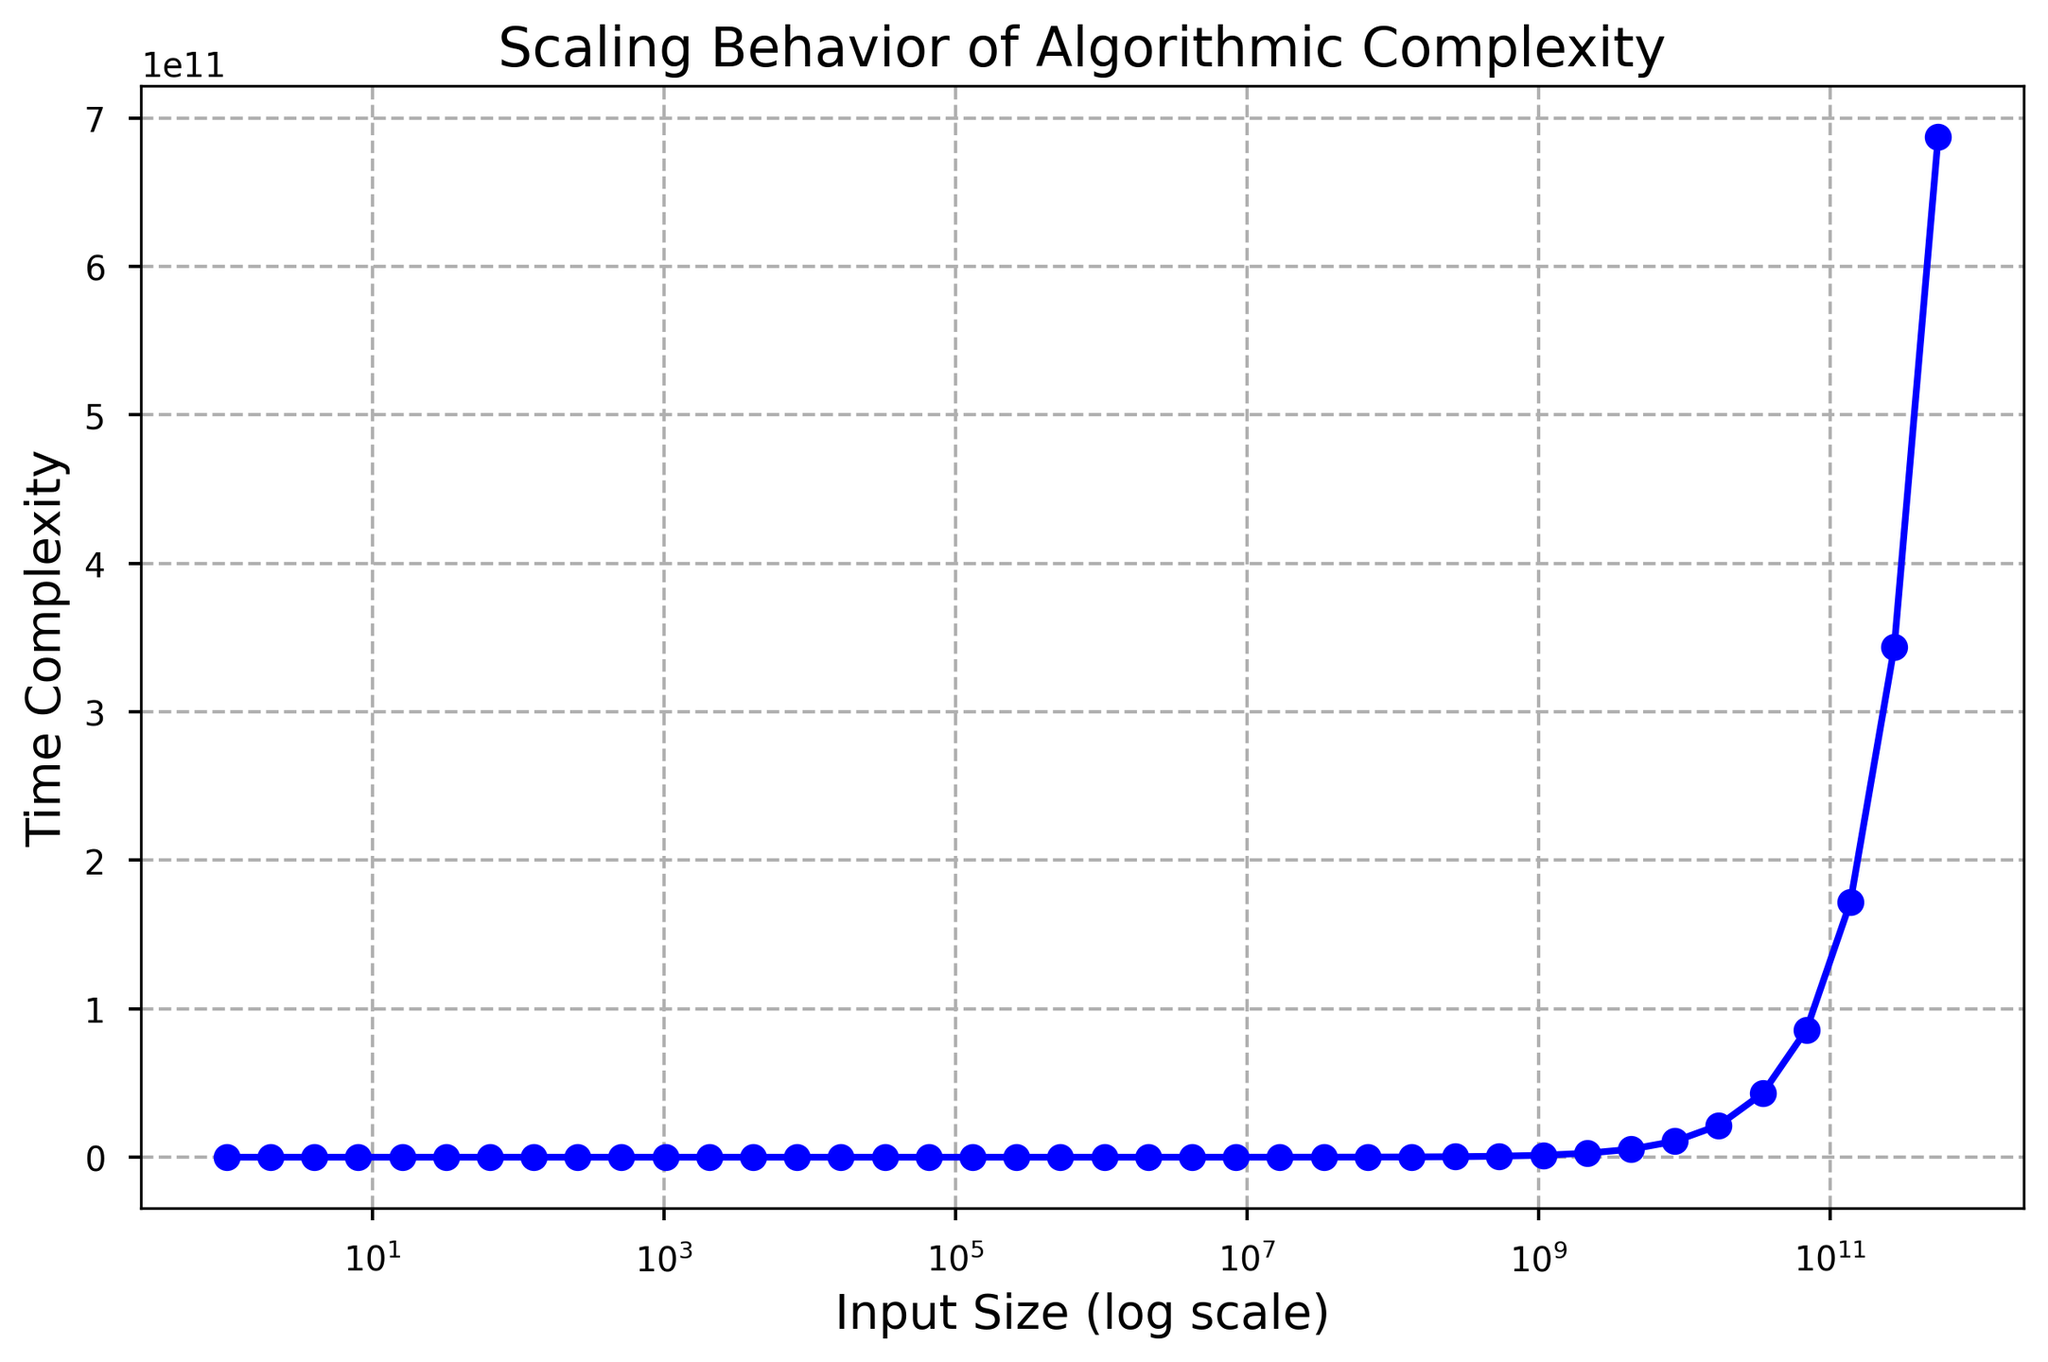What is the input size when the time complexity is 2560? Check the y-axis for the time complexity value of 2560 and follow the corresponding x-axis value. The input size at this point is 2048.
Answer: 2048 Does the time complexity double when the input size is doubled? Comparing the time complexity values for input sizes 2 and 4, 4 and 8, and so on, you observe that each time the input size is doubled, the time complexity also doubles. For example, at 2, time complexity is 2; at 4, it's approximately 5 (not precisely doubled but close), at 8, it's 10, etc.
Answer: Yes Is there a linear relationship between input size and time complexity on the log scale? From the visual representation of the plot, a straight line pattern on the log scale suggests that the input size and time complexity have a linear relationship on the log scale.
Answer: Yes Which input size has the highest time complexity in the plot? Looking at the x-axis, the largest input size is 549755813888, and the corresponding time complexity at this point is 687194767360.
Answer: 549755813888 What is the difference in time complexity between input sizes 2048 and 4096? Locate the time complexity values for input sizes 2048 and 4096 on the y-axis, which are 2560 and 5120 respectively. Subtract the former from the latter: 5120 - 2560 = 2560.
Answer: 2560 Describe the color and markers used in the plot. The line plot uses blue color with circle markers to denote each data point.
Answer: Blue, circles What is the input size when the time complexity is 1342177280? Check the y-axis for the time complexity value of 1342177280 and follow the corresponding x-axis value. The input size at this point is 1073741824.
Answer: 1073741824 What would be the expected time complexity for an input size of 1000? To estimate, note the time complexity at 1024, which is 1280, so the expected value at 1000 should be slightly less than 1280, considering the linear relationship on the log scale.
Answer: Slightly less than 1280 Is the grid in the plot more or less dense for larger input sizes? Observing the plot, the grid becomes more dense for larger input sizes due to the log scale which condenses values as they grow larger.
Answer: More dense 